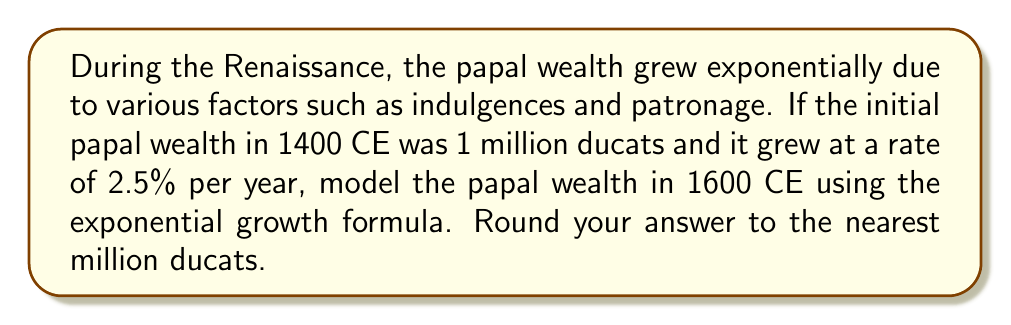Teach me how to tackle this problem. To model the growth of papal wealth over time, we'll use the exponential growth formula:

$$A = P(1 + r)^t$$

Where:
$A$ = Final amount
$P$ = Initial principal balance
$r$ = Annual growth rate (as a decimal)
$t$ = Time in years

Given:
$P = 1,000,000$ ducats (initial wealth in 1400 CE)
$r = 0.025$ (2.5% annual growth rate)
$t = 200$ years (from 1400 CE to 1600 CE)

Let's solve step by step:

1) Plug the values into the formula:
   $$A = 1,000,000(1 + 0.025)^{200}$$

2) Simplify the base of the exponent:
   $$A = 1,000,000(1.025)^{200}$$

3) Calculate the exponent:
   $$A = 1,000,000 \times 141.9829$$

4) Multiply:
   $$A = 141,982,900$$

5) Round to the nearest million:
   $$A \approx 142,000,000$$

Therefore, the model predicts that the papal wealth in 1600 CE would be approximately 142 million ducats.
Answer: 142 million ducats 